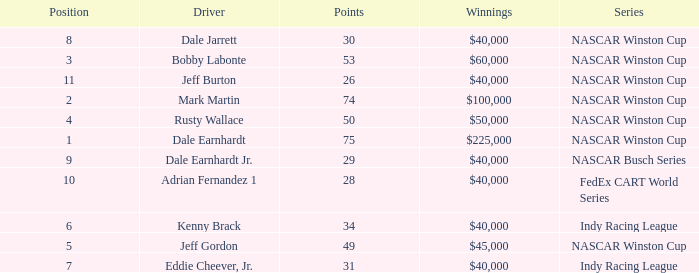In what series did Bobby Labonte drive? NASCAR Winston Cup. 